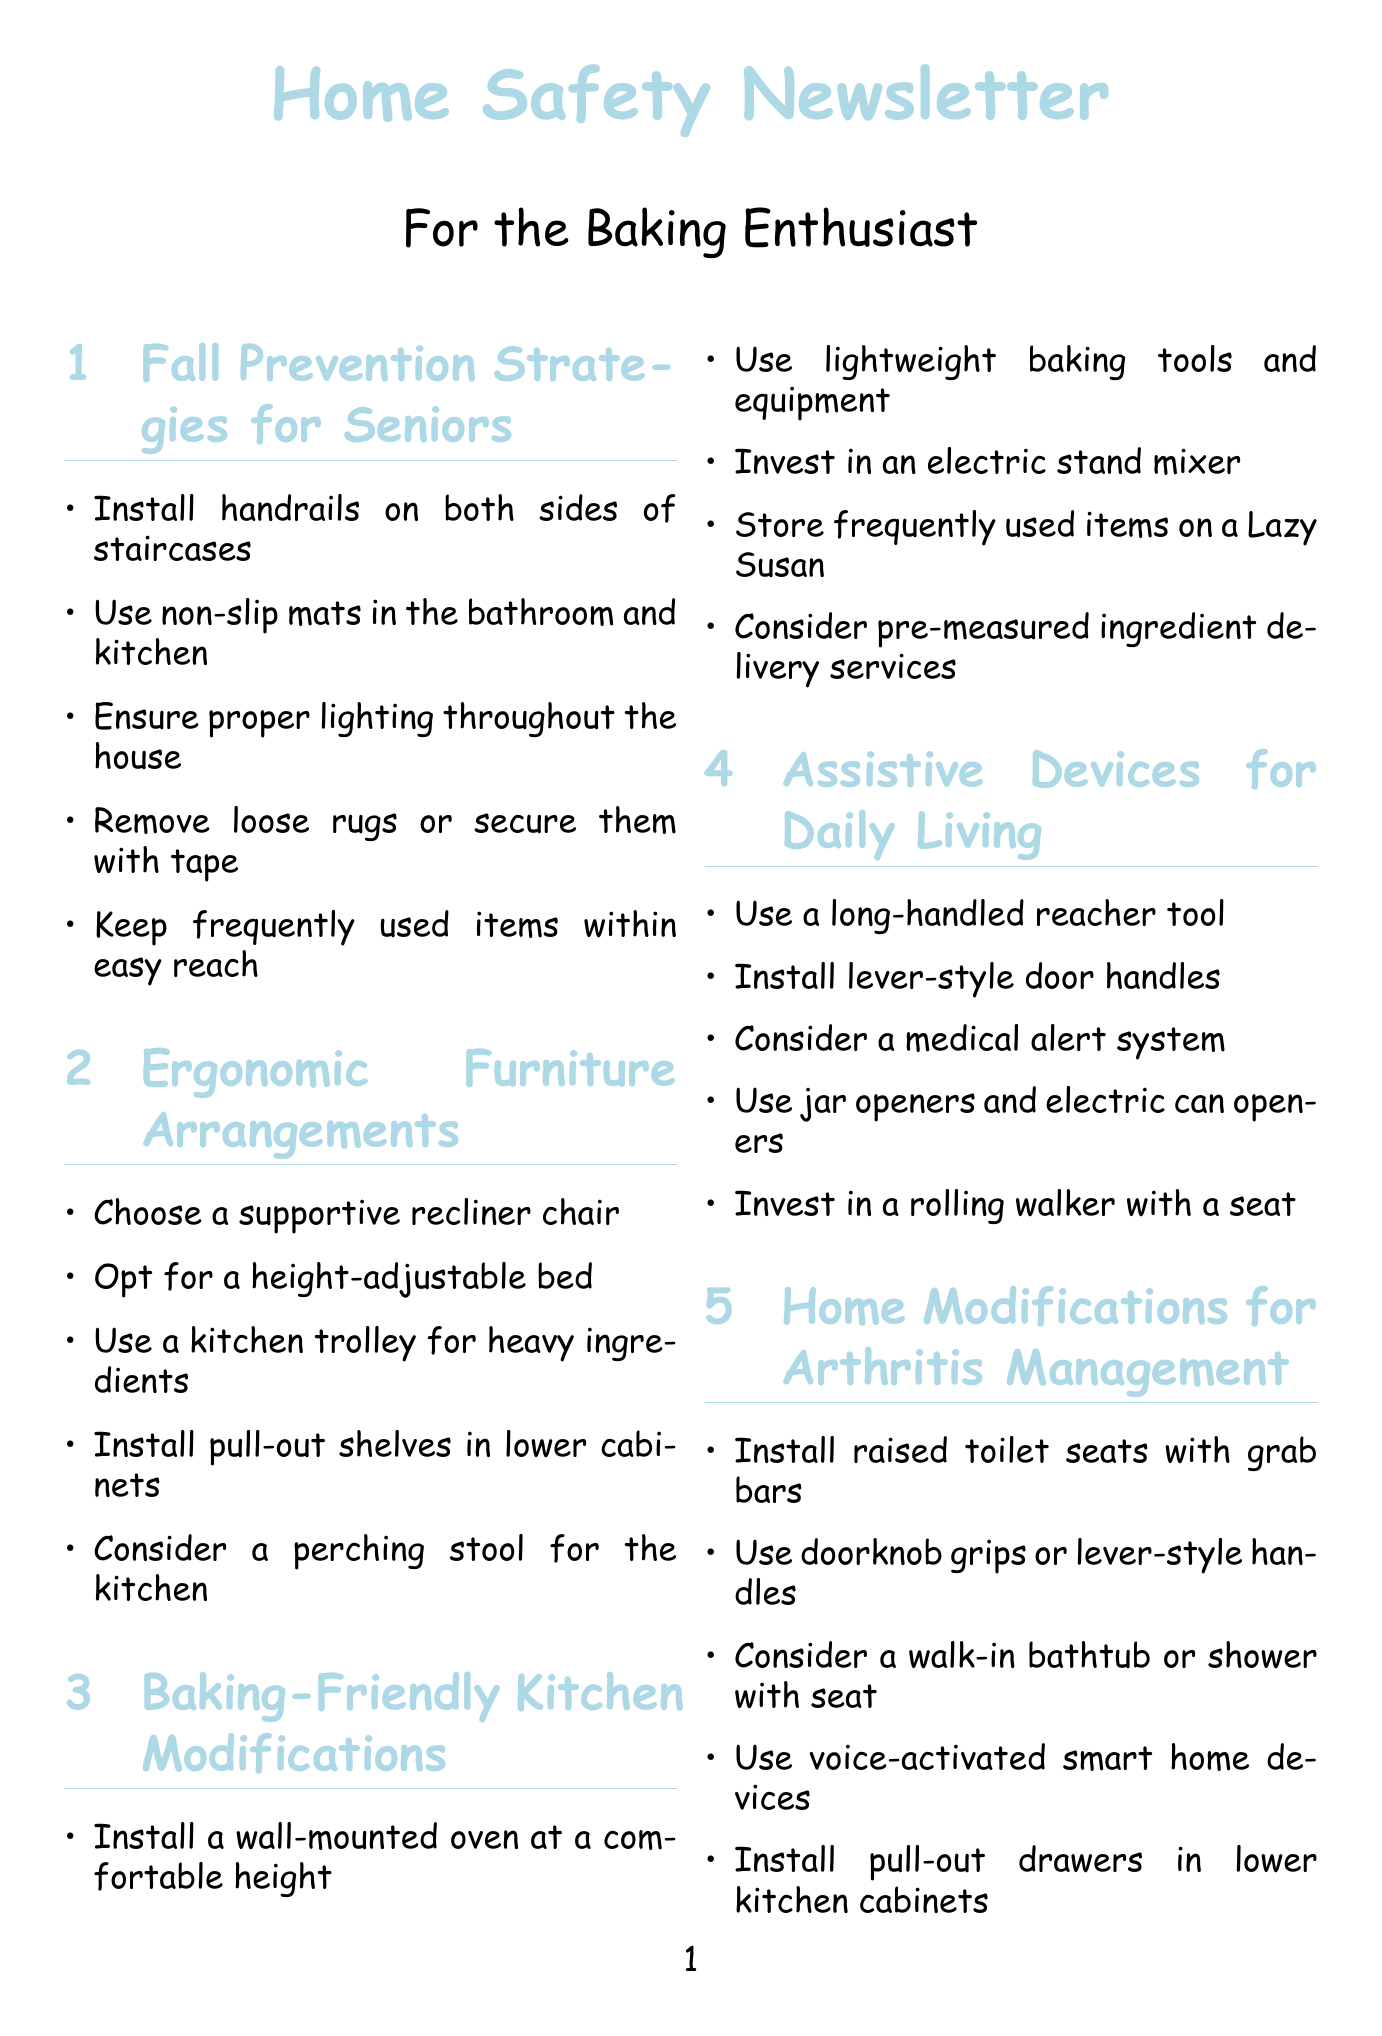What are two fall prevention strategies mentioned? The document lists multiple strategies, specifically, "Install handrails on both sides of staircases" and "Use non-slip mats in the bathroom and kitchen."
Answer: Handrails, non-slip mats What furniture type is recommended for comfort? The document suggests a "supportive recliner chair" for ergonomic arrangements.
Answer: Supportive recliner chair How many baking-friendly kitchen modifications are mentioned? The document presents five modifications specifically for baking-friendly kitchen setups.
Answer: Five What tool can help with heavy transport in the kitchen? The document mentions using "a kitchen trolley" to transport heavy baking ingredients and equipment.
Answer: Kitchen trolley What is the purpose of installing pull-out shelves? Pull-out shelves are recommended to "reduce bending" which makes access easier.
Answer: Reduce bending 